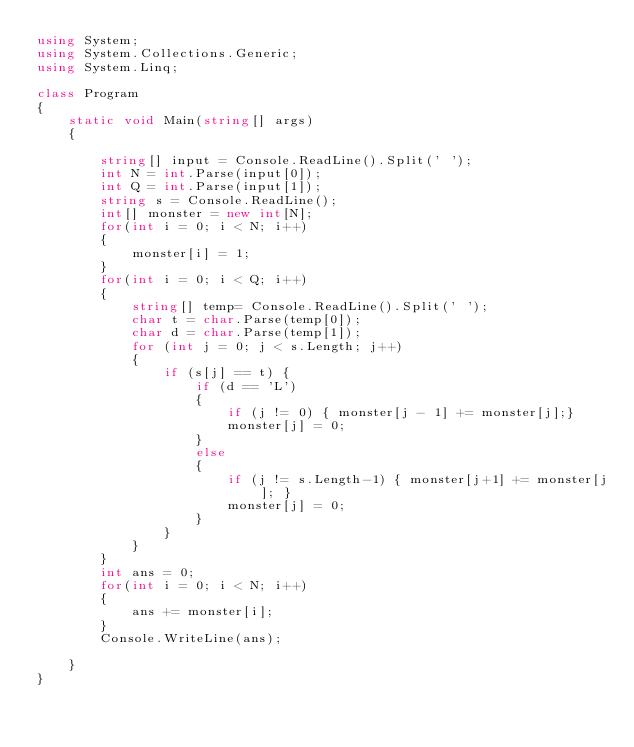Convert code to text. <code><loc_0><loc_0><loc_500><loc_500><_C#_>using System;
using System.Collections.Generic;
using System.Linq;

class Program
{
    static void Main(string[] args)
    {

        string[] input = Console.ReadLine().Split(' ');
        int N = int.Parse(input[0]);
        int Q = int.Parse(input[1]);
        string s = Console.ReadLine();
        int[] monster = new int[N];
        for(int i = 0; i < N; i++)
        {
            monster[i] = 1;
        }
        for(int i = 0; i < Q; i++)
        {
            string[] temp= Console.ReadLine().Split(' ');
            char t = char.Parse(temp[0]);
            char d = char.Parse(temp[1]);
            for (int j = 0; j < s.Length; j++)
            {
                if (s[j] == t) {
                    if (d == 'L')
                    {
                        if (j != 0) { monster[j - 1] += monster[j];}
                        monster[j] = 0;
                    }
                    else
                    {
                        if (j != s.Length-1) { monster[j+1] += monster[j]; }
                        monster[j] = 0;
                    }
                }
            }
        }
        int ans = 0;
        for(int i = 0; i < N; i++)
        {
            ans += monster[i];
        }
        Console.WriteLine(ans);

    }
}

</code> 